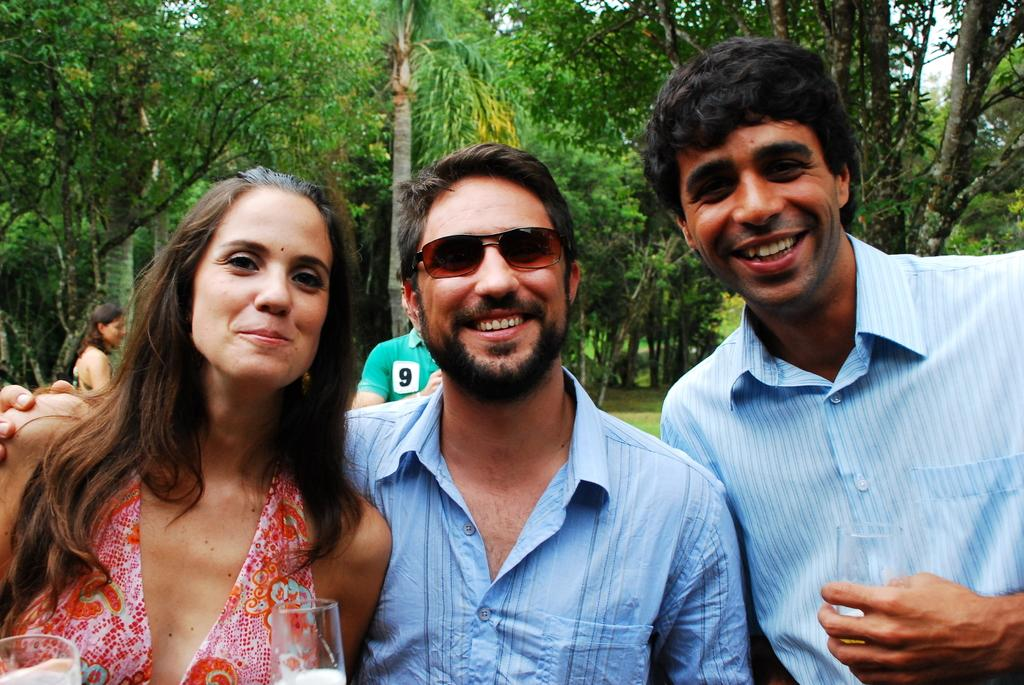What is located in the foreground of the image? There are people in the foreground of the image. What can be seen in the background of the image? There are trees in the background of the image. What type of surprise can be seen on the farm in the image? There is no farm or surprise present in the image; it features people in the foreground and trees in the background. What type of badge is being worn by the people in the image? There is no badge visible on the people in the image. 